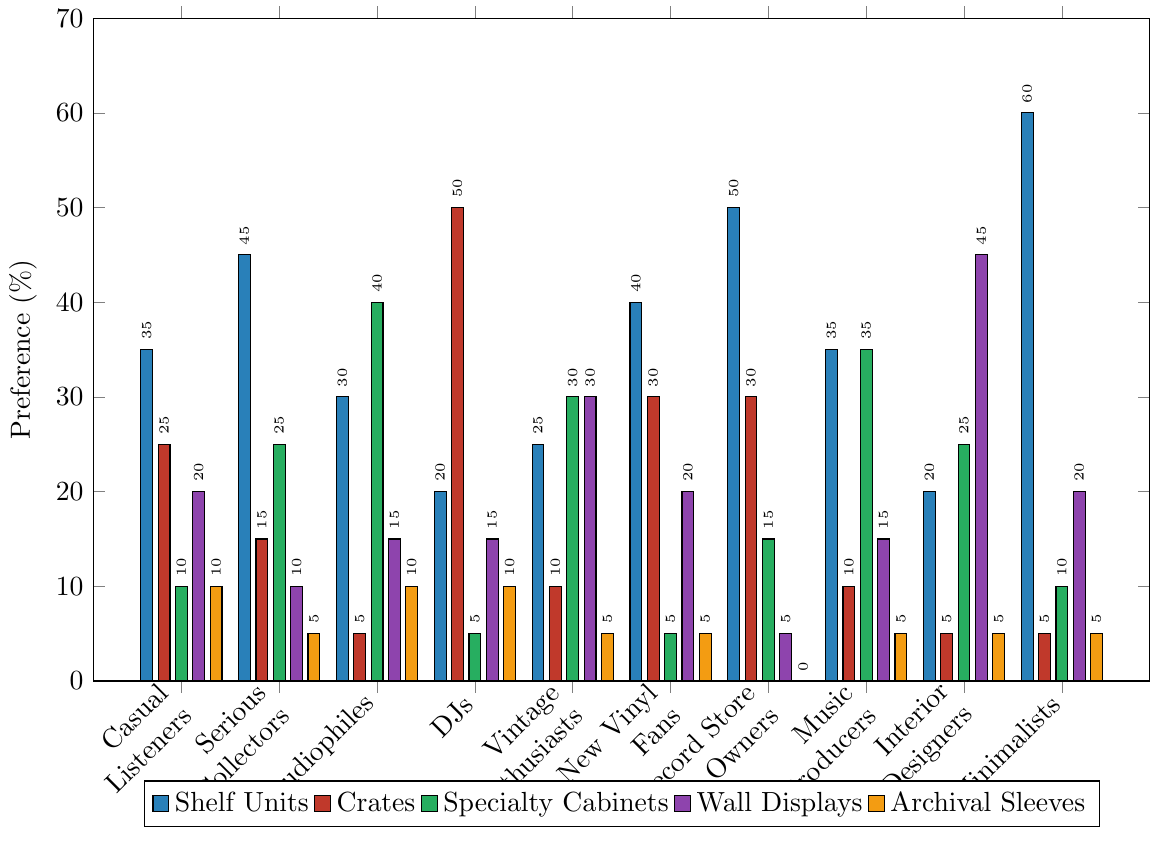Which collector type prefers shelf units the most? To find this, we look for the highest bar in the cluster for shelf units (blue bars). 'Minimalists' have the highest bar at 60%.
Answer: Minimalists Which storage solution is most preferred by DJs? For DJs, we look for the highest bar among their preferences. Crates (red bar) is at 50% which is the highest.
Answer: Crates What is the total preference percentage for 'Specialty Cabinets' across all collector types? Add up the height of the green bars for all collector types: 10 + 25 + 40 + 5 + 30 + 5 + 15 + 35 + 25 + 10 = 200.
Answer: 200% Which collector type has the lowest preference for 'Archival Sleeves'? Look for the shortest yellow bar, which is for 'Record Store Owners' at 0%.
Answer: Record Store Owners Compare the preference percentages of 'Crates' between 'Serious Collectors' and 'DJs'. Which is higher and by how much? For Serious Collectors, Crates is 15%. For DJs, it's 50%. The difference is 50 - 15 = 35%.
Answer: DJs by 35% What is the average preference percentage for 'Wall Displays'? Sum the heights of all the purple bars and divide by the number of collector types. (20 + 10 + 15 + 15 + 30 + 20 + 5 + 15 + 45 + 20) / 10 = 19.5%.
Answer: 19.5% How much more do 'Casual Listeners' prefer 'Crates' over 'Archival Sleeves'? For Casual Listeners, Crates is 25% and Archival Sleeves is 10%. The difference is 25 - 10 = 15%.
Answer: 15% Which storage solution do 'Interior Designers' prefer the least? For Interior Designers, the shortest bar is for 'Crates', which is 5%.
Answer: Crates What is the total preference percentage for 'Shelf Units' among 'Casual Listeners', 'Serious Collectors', and 'New Vinyl Fans'? Sum the heights of the blue bars for these three: 35 + 45 + 40 = 120.
Answer: 120% Do 'Audiophiles' prefer 'Specialty Cabinets' or 'Shelf Units' more, and by how much? 'Audiophiles' prefer Specialty Cabinets (40%) over Shelf Units (30%) by 40 - 30 = 10%.
Answer: Specialty Cabinets by 10% 